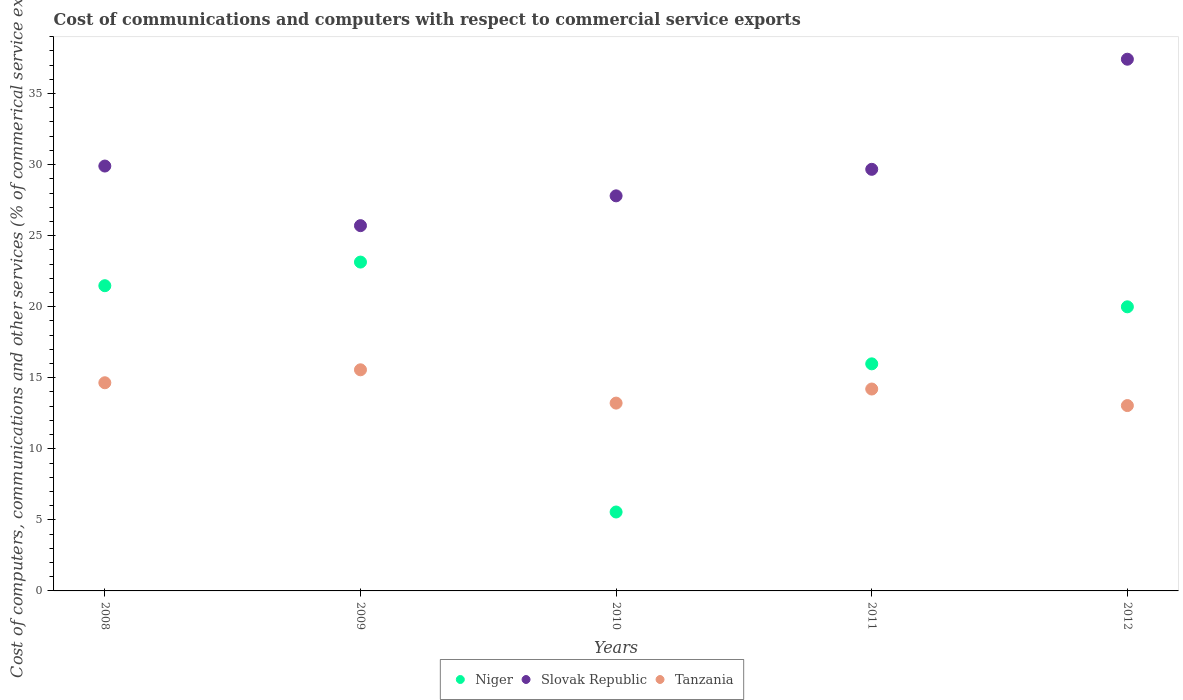How many different coloured dotlines are there?
Ensure brevity in your answer.  3. Is the number of dotlines equal to the number of legend labels?
Ensure brevity in your answer.  Yes. What is the cost of communications and computers in Tanzania in 2011?
Provide a short and direct response. 14.21. Across all years, what is the maximum cost of communications and computers in Tanzania?
Give a very brief answer. 15.56. Across all years, what is the minimum cost of communications and computers in Tanzania?
Your answer should be very brief. 13.04. In which year was the cost of communications and computers in Niger maximum?
Make the answer very short. 2009. In which year was the cost of communications and computers in Tanzania minimum?
Provide a short and direct response. 2012. What is the total cost of communications and computers in Slovak Republic in the graph?
Ensure brevity in your answer.  150.49. What is the difference between the cost of communications and computers in Tanzania in 2008 and that in 2009?
Offer a terse response. -0.91. What is the difference between the cost of communications and computers in Tanzania in 2010 and the cost of communications and computers in Slovak Republic in 2009?
Give a very brief answer. -12.49. What is the average cost of communications and computers in Niger per year?
Make the answer very short. 17.23. In the year 2009, what is the difference between the cost of communications and computers in Tanzania and cost of communications and computers in Slovak Republic?
Provide a succinct answer. -10.14. In how many years, is the cost of communications and computers in Niger greater than 29 %?
Offer a terse response. 0. What is the ratio of the cost of communications and computers in Slovak Republic in 2008 to that in 2009?
Ensure brevity in your answer.  1.16. Is the difference between the cost of communications and computers in Tanzania in 2008 and 2009 greater than the difference between the cost of communications and computers in Slovak Republic in 2008 and 2009?
Ensure brevity in your answer.  No. What is the difference between the highest and the second highest cost of communications and computers in Niger?
Make the answer very short. 1.66. What is the difference between the highest and the lowest cost of communications and computers in Tanzania?
Your answer should be compact. 2.52. In how many years, is the cost of communications and computers in Niger greater than the average cost of communications and computers in Niger taken over all years?
Make the answer very short. 3. Is it the case that in every year, the sum of the cost of communications and computers in Slovak Republic and cost of communications and computers in Niger  is greater than the cost of communications and computers in Tanzania?
Your answer should be very brief. Yes. Is the cost of communications and computers in Tanzania strictly greater than the cost of communications and computers in Niger over the years?
Make the answer very short. No. Is the cost of communications and computers in Niger strictly less than the cost of communications and computers in Tanzania over the years?
Offer a terse response. No. How many dotlines are there?
Provide a succinct answer. 3. How many years are there in the graph?
Your answer should be compact. 5. What is the difference between two consecutive major ticks on the Y-axis?
Keep it short and to the point. 5. Are the values on the major ticks of Y-axis written in scientific E-notation?
Make the answer very short. No. Does the graph contain any zero values?
Offer a very short reply. No. Does the graph contain grids?
Offer a very short reply. No. How many legend labels are there?
Your answer should be very brief. 3. How are the legend labels stacked?
Offer a very short reply. Horizontal. What is the title of the graph?
Keep it short and to the point. Cost of communications and computers with respect to commercial service exports. Does "Slovak Republic" appear as one of the legend labels in the graph?
Keep it short and to the point. Yes. What is the label or title of the X-axis?
Provide a succinct answer. Years. What is the label or title of the Y-axis?
Offer a terse response. Cost of computers, communications and other services (% of commerical service exports). What is the Cost of computers, communications and other services (% of commerical service exports) of Niger in 2008?
Your response must be concise. 21.48. What is the Cost of computers, communications and other services (% of commerical service exports) in Slovak Republic in 2008?
Keep it short and to the point. 29.9. What is the Cost of computers, communications and other services (% of commerical service exports) of Tanzania in 2008?
Your answer should be compact. 14.65. What is the Cost of computers, communications and other services (% of commerical service exports) of Niger in 2009?
Provide a short and direct response. 23.14. What is the Cost of computers, communications and other services (% of commerical service exports) in Slovak Republic in 2009?
Offer a terse response. 25.71. What is the Cost of computers, communications and other services (% of commerical service exports) of Tanzania in 2009?
Provide a succinct answer. 15.56. What is the Cost of computers, communications and other services (% of commerical service exports) of Niger in 2010?
Give a very brief answer. 5.55. What is the Cost of computers, communications and other services (% of commerical service exports) in Slovak Republic in 2010?
Offer a terse response. 27.8. What is the Cost of computers, communications and other services (% of commerical service exports) in Tanzania in 2010?
Your answer should be very brief. 13.22. What is the Cost of computers, communications and other services (% of commerical service exports) in Niger in 2011?
Your answer should be very brief. 15.98. What is the Cost of computers, communications and other services (% of commerical service exports) in Slovak Republic in 2011?
Ensure brevity in your answer.  29.67. What is the Cost of computers, communications and other services (% of commerical service exports) of Tanzania in 2011?
Ensure brevity in your answer.  14.21. What is the Cost of computers, communications and other services (% of commerical service exports) in Niger in 2012?
Provide a succinct answer. 19.99. What is the Cost of computers, communications and other services (% of commerical service exports) in Slovak Republic in 2012?
Give a very brief answer. 37.42. What is the Cost of computers, communications and other services (% of commerical service exports) in Tanzania in 2012?
Offer a very short reply. 13.04. Across all years, what is the maximum Cost of computers, communications and other services (% of commerical service exports) of Niger?
Your answer should be compact. 23.14. Across all years, what is the maximum Cost of computers, communications and other services (% of commerical service exports) of Slovak Republic?
Give a very brief answer. 37.42. Across all years, what is the maximum Cost of computers, communications and other services (% of commerical service exports) of Tanzania?
Offer a terse response. 15.56. Across all years, what is the minimum Cost of computers, communications and other services (% of commerical service exports) of Niger?
Ensure brevity in your answer.  5.55. Across all years, what is the minimum Cost of computers, communications and other services (% of commerical service exports) of Slovak Republic?
Offer a very short reply. 25.71. Across all years, what is the minimum Cost of computers, communications and other services (% of commerical service exports) in Tanzania?
Your answer should be very brief. 13.04. What is the total Cost of computers, communications and other services (% of commerical service exports) in Niger in the graph?
Provide a short and direct response. 86.15. What is the total Cost of computers, communications and other services (% of commerical service exports) of Slovak Republic in the graph?
Ensure brevity in your answer.  150.49. What is the total Cost of computers, communications and other services (% of commerical service exports) in Tanzania in the graph?
Your answer should be compact. 70.68. What is the difference between the Cost of computers, communications and other services (% of commerical service exports) of Niger in 2008 and that in 2009?
Offer a very short reply. -1.66. What is the difference between the Cost of computers, communications and other services (% of commerical service exports) in Slovak Republic in 2008 and that in 2009?
Offer a terse response. 4.19. What is the difference between the Cost of computers, communications and other services (% of commerical service exports) in Tanzania in 2008 and that in 2009?
Provide a short and direct response. -0.91. What is the difference between the Cost of computers, communications and other services (% of commerical service exports) in Niger in 2008 and that in 2010?
Offer a very short reply. 15.93. What is the difference between the Cost of computers, communications and other services (% of commerical service exports) of Slovak Republic in 2008 and that in 2010?
Make the answer very short. 2.1. What is the difference between the Cost of computers, communications and other services (% of commerical service exports) in Tanzania in 2008 and that in 2010?
Ensure brevity in your answer.  1.43. What is the difference between the Cost of computers, communications and other services (% of commerical service exports) in Niger in 2008 and that in 2011?
Your answer should be very brief. 5.5. What is the difference between the Cost of computers, communications and other services (% of commerical service exports) in Slovak Republic in 2008 and that in 2011?
Your response must be concise. 0.23. What is the difference between the Cost of computers, communications and other services (% of commerical service exports) in Tanzania in 2008 and that in 2011?
Provide a short and direct response. 0.44. What is the difference between the Cost of computers, communications and other services (% of commerical service exports) of Niger in 2008 and that in 2012?
Ensure brevity in your answer.  1.49. What is the difference between the Cost of computers, communications and other services (% of commerical service exports) in Slovak Republic in 2008 and that in 2012?
Offer a very short reply. -7.52. What is the difference between the Cost of computers, communications and other services (% of commerical service exports) of Tanzania in 2008 and that in 2012?
Make the answer very short. 1.61. What is the difference between the Cost of computers, communications and other services (% of commerical service exports) in Niger in 2009 and that in 2010?
Ensure brevity in your answer.  17.59. What is the difference between the Cost of computers, communications and other services (% of commerical service exports) in Slovak Republic in 2009 and that in 2010?
Provide a short and direct response. -2.1. What is the difference between the Cost of computers, communications and other services (% of commerical service exports) in Tanzania in 2009 and that in 2010?
Provide a short and direct response. 2.34. What is the difference between the Cost of computers, communications and other services (% of commerical service exports) in Niger in 2009 and that in 2011?
Keep it short and to the point. 7.16. What is the difference between the Cost of computers, communications and other services (% of commerical service exports) of Slovak Republic in 2009 and that in 2011?
Your response must be concise. -3.96. What is the difference between the Cost of computers, communications and other services (% of commerical service exports) of Tanzania in 2009 and that in 2011?
Give a very brief answer. 1.35. What is the difference between the Cost of computers, communications and other services (% of commerical service exports) of Niger in 2009 and that in 2012?
Offer a terse response. 3.15. What is the difference between the Cost of computers, communications and other services (% of commerical service exports) of Slovak Republic in 2009 and that in 2012?
Give a very brief answer. -11.71. What is the difference between the Cost of computers, communications and other services (% of commerical service exports) in Tanzania in 2009 and that in 2012?
Provide a short and direct response. 2.52. What is the difference between the Cost of computers, communications and other services (% of commerical service exports) of Niger in 2010 and that in 2011?
Ensure brevity in your answer.  -10.43. What is the difference between the Cost of computers, communications and other services (% of commerical service exports) in Slovak Republic in 2010 and that in 2011?
Make the answer very short. -1.87. What is the difference between the Cost of computers, communications and other services (% of commerical service exports) in Tanzania in 2010 and that in 2011?
Provide a short and direct response. -0.99. What is the difference between the Cost of computers, communications and other services (% of commerical service exports) of Niger in 2010 and that in 2012?
Make the answer very short. -14.44. What is the difference between the Cost of computers, communications and other services (% of commerical service exports) of Slovak Republic in 2010 and that in 2012?
Your answer should be very brief. -9.62. What is the difference between the Cost of computers, communications and other services (% of commerical service exports) in Tanzania in 2010 and that in 2012?
Offer a very short reply. 0.17. What is the difference between the Cost of computers, communications and other services (% of commerical service exports) in Niger in 2011 and that in 2012?
Give a very brief answer. -4.01. What is the difference between the Cost of computers, communications and other services (% of commerical service exports) in Slovak Republic in 2011 and that in 2012?
Your answer should be compact. -7.75. What is the difference between the Cost of computers, communications and other services (% of commerical service exports) in Tanzania in 2011 and that in 2012?
Your answer should be very brief. 1.16. What is the difference between the Cost of computers, communications and other services (% of commerical service exports) of Niger in 2008 and the Cost of computers, communications and other services (% of commerical service exports) of Slovak Republic in 2009?
Provide a short and direct response. -4.23. What is the difference between the Cost of computers, communications and other services (% of commerical service exports) in Niger in 2008 and the Cost of computers, communications and other services (% of commerical service exports) in Tanzania in 2009?
Your response must be concise. 5.92. What is the difference between the Cost of computers, communications and other services (% of commerical service exports) of Slovak Republic in 2008 and the Cost of computers, communications and other services (% of commerical service exports) of Tanzania in 2009?
Your answer should be very brief. 14.34. What is the difference between the Cost of computers, communications and other services (% of commerical service exports) of Niger in 2008 and the Cost of computers, communications and other services (% of commerical service exports) of Slovak Republic in 2010?
Provide a succinct answer. -6.32. What is the difference between the Cost of computers, communications and other services (% of commerical service exports) in Niger in 2008 and the Cost of computers, communications and other services (% of commerical service exports) in Tanzania in 2010?
Offer a very short reply. 8.26. What is the difference between the Cost of computers, communications and other services (% of commerical service exports) in Slovak Republic in 2008 and the Cost of computers, communications and other services (% of commerical service exports) in Tanzania in 2010?
Provide a short and direct response. 16.68. What is the difference between the Cost of computers, communications and other services (% of commerical service exports) in Niger in 2008 and the Cost of computers, communications and other services (% of commerical service exports) in Slovak Republic in 2011?
Your answer should be compact. -8.19. What is the difference between the Cost of computers, communications and other services (% of commerical service exports) of Niger in 2008 and the Cost of computers, communications and other services (% of commerical service exports) of Tanzania in 2011?
Give a very brief answer. 7.27. What is the difference between the Cost of computers, communications and other services (% of commerical service exports) of Slovak Republic in 2008 and the Cost of computers, communications and other services (% of commerical service exports) of Tanzania in 2011?
Make the answer very short. 15.69. What is the difference between the Cost of computers, communications and other services (% of commerical service exports) in Niger in 2008 and the Cost of computers, communications and other services (% of commerical service exports) in Slovak Republic in 2012?
Offer a very short reply. -15.94. What is the difference between the Cost of computers, communications and other services (% of commerical service exports) in Niger in 2008 and the Cost of computers, communications and other services (% of commerical service exports) in Tanzania in 2012?
Your answer should be compact. 8.44. What is the difference between the Cost of computers, communications and other services (% of commerical service exports) in Slovak Republic in 2008 and the Cost of computers, communications and other services (% of commerical service exports) in Tanzania in 2012?
Make the answer very short. 16.86. What is the difference between the Cost of computers, communications and other services (% of commerical service exports) of Niger in 2009 and the Cost of computers, communications and other services (% of commerical service exports) of Slovak Republic in 2010?
Ensure brevity in your answer.  -4.66. What is the difference between the Cost of computers, communications and other services (% of commerical service exports) of Niger in 2009 and the Cost of computers, communications and other services (% of commerical service exports) of Tanzania in 2010?
Give a very brief answer. 9.92. What is the difference between the Cost of computers, communications and other services (% of commerical service exports) of Slovak Republic in 2009 and the Cost of computers, communications and other services (% of commerical service exports) of Tanzania in 2010?
Provide a succinct answer. 12.49. What is the difference between the Cost of computers, communications and other services (% of commerical service exports) of Niger in 2009 and the Cost of computers, communications and other services (% of commerical service exports) of Slovak Republic in 2011?
Your answer should be compact. -6.53. What is the difference between the Cost of computers, communications and other services (% of commerical service exports) in Niger in 2009 and the Cost of computers, communications and other services (% of commerical service exports) in Tanzania in 2011?
Offer a very short reply. 8.93. What is the difference between the Cost of computers, communications and other services (% of commerical service exports) in Slovak Republic in 2009 and the Cost of computers, communications and other services (% of commerical service exports) in Tanzania in 2011?
Ensure brevity in your answer.  11.5. What is the difference between the Cost of computers, communications and other services (% of commerical service exports) of Niger in 2009 and the Cost of computers, communications and other services (% of commerical service exports) of Slovak Republic in 2012?
Make the answer very short. -14.28. What is the difference between the Cost of computers, communications and other services (% of commerical service exports) in Niger in 2009 and the Cost of computers, communications and other services (% of commerical service exports) in Tanzania in 2012?
Your answer should be very brief. 10.1. What is the difference between the Cost of computers, communications and other services (% of commerical service exports) in Slovak Republic in 2009 and the Cost of computers, communications and other services (% of commerical service exports) in Tanzania in 2012?
Your response must be concise. 12.66. What is the difference between the Cost of computers, communications and other services (% of commerical service exports) of Niger in 2010 and the Cost of computers, communications and other services (% of commerical service exports) of Slovak Republic in 2011?
Offer a terse response. -24.12. What is the difference between the Cost of computers, communications and other services (% of commerical service exports) of Niger in 2010 and the Cost of computers, communications and other services (% of commerical service exports) of Tanzania in 2011?
Your answer should be very brief. -8.65. What is the difference between the Cost of computers, communications and other services (% of commerical service exports) of Slovak Republic in 2010 and the Cost of computers, communications and other services (% of commerical service exports) of Tanzania in 2011?
Your answer should be very brief. 13.59. What is the difference between the Cost of computers, communications and other services (% of commerical service exports) of Niger in 2010 and the Cost of computers, communications and other services (% of commerical service exports) of Slovak Republic in 2012?
Give a very brief answer. -31.86. What is the difference between the Cost of computers, communications and other services (% of commerical service exports) in Niger in 2010 and the Cost of computers, communications and other services (% of commerical service exports) in Tanzania in 2012?
Keep it short and to the point. -7.49. What is the difference between the Cost of computers, communications and other services (% of commerical service exports) in Slovak Republic in 2010 and the Cost of computers, communications and other services (% of commerical service exports) in Tanzania in 2012?
Give a very brief answer. 14.76. What is the difference between the Cost of computers, communications and other services (% of commerical service exports) of Niger in 2011 and the Cost of computers, communications and other services (% of commerical service exports) of Slovak Republic in 2012?
Provide a succinct answer. -21.44. What is the difference between the Cost of computers, communications and other services (% of commerical service exports) of Niger in 2011 and the Cost of computers, communications and other services (% of commerical service exports) of Tanzania in 2012?
Your answer should be compact. 2.94. What is the difference between the Cost of computers, communications and other services (% of commerical service exports) of Slovak Republic in 2011 and the Cost of computers, communications and other services (% of commerical service exports) of Tanzania in 2012?
Keep it short and to the point. 16.63. What is the average Cost of computers, communications and other services (% of commerical service exports) in Niger per year?
Give a very brief answer. 17.23. What is the average Cost of computers, communications and other services (% of commerical service exports) of Slovak Republic per year?
Keep it short and to the point. 30.1. What is the average Cost of computers, communications and other services (% of commerical service exports) of Tanzania per year?
Your answer should be very brief. 14.14. In the year 2008, what is the difference between the Cost of computers, communications and other services (% of commerical service exports) of Niger and Cost of computers, communications and other services (% of commerical service exports) of Slovak Republic?
Provide a succinct answer. -8.42. In the year 2008, what is the difference between the Cost of computers, communications and other services (% of commerical service exports) in Niger and Cost of computers, communications and other services (% of commerical service exports) in Tanzania?
Keep it short and to the point. 6.83. In the year 2008, what is the difference between the Cost of computers, communications and other services (% of commerical service exports) of Slovak Republic and Cost of computers, communications and other services (% of commerical service exports) of Tanzania?
Provide a short and direct response. 15.25. In the year 2009, what is the difference between the Cost of computers, communications and other services (% of commerical service exports) of Niger and Cost of computers, communications and other services (% of commerical service exports) of Slovak Republic?
Give a very brief answer. -2.56. In the year 2009, what is the difference between the Cost of computers, communications and other services (% of commerical service exports) of Niger and Cost of computers, communications and other services (% of commerical service exports) of Tanzania?
Make the answer very short. 7.58. In the year 2009, what is the difference between the Cost of computers, communications and other services (% of commerical service exports) of Slovak Republic and Cost of computers, communications and other services (% of commerical service exports) of Tanzania?
Ensure brevity in your answer.  10.14. In the year 2010, what is the difference between the Cost of computers, communications and other services (% of commerical service exports) of Niger and Cost of computers, communications and other services (% of commerical service exports) of Slovak Republic?
Make the answer very short. -22.25. In the year 2010, what is the difference between the Cost of computers, communications and other services (% of commerical service exports) of Niger and Cost of computers, communications and other services (% of commerical service exports) of Tanzania?
Your answer should be very brief. -7.66. In the year 2010, what is the difference between the Cost of computers, communications and other services (% of commerical service exports) of Slovak Republic and Cost of computers, communications and other services (% of commerical service exports) of Tanzania?
Give a very brief answer. 14.59. In the year 2011, what is the difference between the Cost of computers, communications and other services (% of commerical service exports) in Niger and Cost of computers, communications and other services (% of commerical service exports) in Slovak Republic?
Offer a terse response. -13.69. In the year 2011, what is the difference between the Cost of computers, communications and other services (% of commerical service exports) of Niger and Cost of computers, communications and other services (% of commerical service exports) of Tanzania?
Provide a short and direct response. 1.77. In the year 2011, what is the difference between the Cost of computers, communications and other services (% of commerical service exports) of Slovak Republic and Cost of computers, communications and other services (% of commerical service exports) of Tanzania?
Give a very brief answer. 15.46. In the year 2012, what is the difference between the Cost of computers, communications and other services (% of commerical service exports) in Niger and Cost of computers, communications and other services (% of commerical service exports) in Slovak Republic?
Give a very brief answer. -17.42. In the year 2012, what is the difference between the Cost of computers, communications and other services (% of commerical service exports) in Niger and Cost of computers, communications and other services (% of commerical service exports) in Tanzania?
Your response must be concise. 6.95. In the year 2012, what is the difference between the Cost of computers, communications and other services (% of commerical service exports) of Slovak Republic and Cost of computers, communications and other services (% of commerical service exports) of Tanzania?
Give a very brief answer. 24.37. What is the ratio of the Cost of computers, communications and other services (% of commerical service exports) in Niger in 2008 to that in 2009?
Make the answer very short. 0.93. What is the ratio of the Cost of computers, communications and other services (% of commerical service exports) of Slovak Republic in 2008 to that in 2009?
Make the answer very short. 1.16. What is the ratio of the Cost of computers, communications and other services (% of commerical service exports) in Tanzania in 2008 to that in 2009?
Give a very brief answer. 0.94. What is the ratio of the Cost of computers, communications and other services (% of commerical service exports) of Niger in 2008 to that in 2010?
Provide a succinct answer. 3.87. What is the ratio of the Cost of computers, communications and other services (% of commerical service exports) of Slovak Republic in 2008 to that in 2010?
Offer a terse response. 1.08. What is the ratio of the Cost of computers, communications and other services (% of commerical service exports) of Tanzania in 2008 to that in 2010?
Your answer should be compact. 1.11. What is the ratio of the Cost of computers, communications and other services (% of commerical service exports) of Niger in 2008 to that in 2011?
Provide a succinct answer. 1.34. What is the ratio of the Cost of computers, communications and other services (% of commerical service exports) in Tanzania in 2008 to that in 2011?
Your answer should be compact. 1.03. What is the ratio of the Cost of computers, communications and other services (% of commerical service exports) in Niger in 2008 to that in 2012?
Your answer should be very brief. 1.07. What is the ratio of the Cost of computers, communications and other services (% of commerical service exports) of Slovak Republic in 2008 to that in 2012?
Provide a short and direct response. 0.8. What is the ratio of the Cost of computers, communications and other services (% of commerical service exports) in Tanzania in 2008 to that in 2012?
Your answer should be compact. 1.12. What is the ratio of the Cost of computers, communications and other services (% of commerical service exports) of Niger in 2009 to that in 2010?
Make the answer very short. 4.17. What is the ratio of the Cost of computers, communications and other services (% of commerical service exports) in Slovak Republic in 2009 to that in 2010?
Ensure brevity in your answer.  0.92. What is the ratio of the Cost of computers, communications and other services (% of commerical service exports) in Tanzania in 2009 to that in 2010?
Your answer should be compact. 1.18. What is the ratio of the Cost of computers, communications and other services (% of commerical service exports) in Niger in 2009 to that in 2011?
Offer a very short reply. 1.45. What is the ratio of the Cost of computers, communications and other services (% of commerical service exports) in Slovak Republic in 2009 to that in 2011?
Make the answer very short. 0.87. What is the ratio of the Cost of computers, communications and other services (% of commerical service exports) in Tanzania in 2009 to that in 2011?
Keep it short and to the point. 1.1. What is the ratio of the Cost of computers, communications and other services (% of commerical service exports) in Niger in 2009 to that in 2012?
Offer a very short reply. 1.16. What is the ratio of the Cost of computers, communications and other services (% of commerical service exports) in Slovak Republic in 2009 to that in 2012?
Keep it short and to the point. 0.69. What is the ratio of the Cost of computers, communications and other services (% of commerical service exports) in Tanzania in 2009 to that in 2012?
Offer a terse response. 1.19. What is the ratio of the Cost of computers, communications and other services (% of commerical service exports) in Niger in 2010 to that in 2011?
Ensure brevity in your answer.  0.35. What is the ratio of the Cost of computers, communications and other services (% of commerical service exports) in Slovak Republic in 2010 to that in 2011?
Keep it short and to the point. 0.94. What is the ratio of the Cost of computers, communications and other services (% of commerical service exports) of Tanzania in 2010 to that in 2011?
Your response must be concise. 0.93. What is the ratio of the Cost of computers, communications and other services (% of commerical service exports) in Niger in 2010 to that in 2012?
Make the answer very short. 0.28. What is the ratio of the Cost of computers, communications and other services (% of commerical service exports) of Slovak Republic in 2010 to that in 2012?
Your response must be concise. 0.74. What is the ratio of the Cost of computers, communications and other services (% of commerical service exports) in Tanzania in 2010 to that in 2012?
Make the answer very short. 1.01. What is the ratio of the Cost of computers, communications and other services (% of commerical service exports) in Niger in 2011 to that in 2012?
Your response must be concise. 0.8. What is the ratio of the Cost of computers, communications and other services (% of commerical service exports) in Slovak Republic in 2011 to that in 2012?
Make the answer very short. 0.79. What is the ratio of the Cost of computers, communications and other services (% of commerical service exports) of Tanzania in 2011 to that in 2012?
Your answer should be compact. 1.09. What is the difference between the highest and the second highest Cost of computers, communications and other services (% of commerical service exports) of Niger?
Keep it short and to the point. 1.66. What is the difference between the highest and the second highest Cost of computers, communications and other services (% of commerical service exports) of Slovak Republic?
Ensure brevity in your answer.  7.52. What is the difference between the highest and the second highest Cost of computers, communications and other services (% of commerical service exports) of Tanzania?
Provide a short and direct response. 0.91. What is the difference between the highest and the lowest Cost of computers, communications and other services (% of commerical service exports) of Niger?
Give a very brief answer. 17.59. What is the difference between the highest and the lowest Cost of computers, communications and other services (% of commerical service exports) in Slovak Republic?
Make the answer very short. 11.71. What is the difference between the highest and the lowest Cost of computers, communications and other services (% of commerical service exports) in Tanzania?
Your answer should be compact. 2.52. 